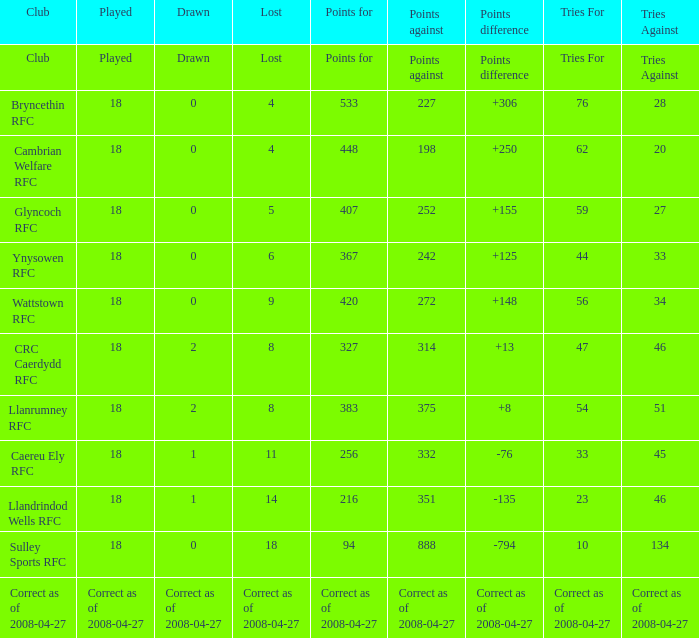What is the value of the item "Points" when the value of the item "Points against" is 272? 420.0. 